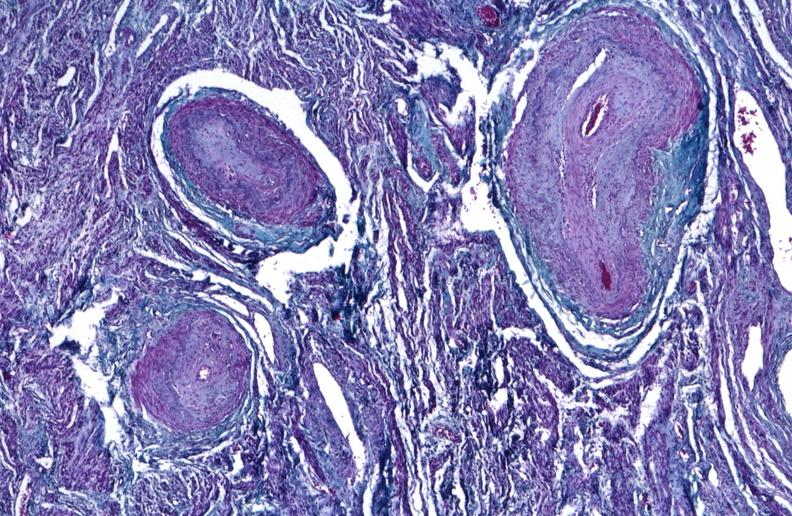where is this?
Answer the question using a single word or phrase. Urinary 